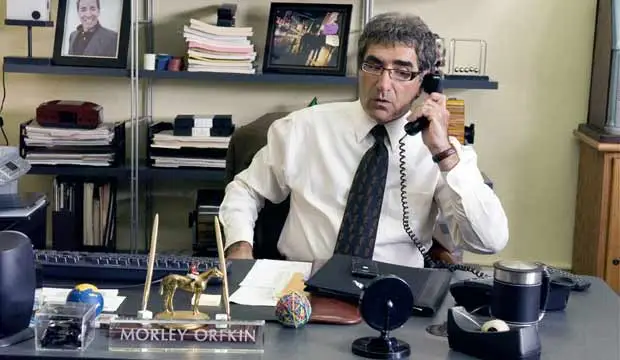How does the setting contribute to the ambiance of the scene? The office setting, with its practical furnishings and personal memorabilia, creates an intimate yet professional ambiance. This backdrop might emphasize the character's profound connection with his work, possibly inferring his dedication or the nature of his profession. Is there anything in the picture that suggests the character's personality or backstory? The unique combination of items like the framed photo, which possibly portrays a personal achievement or relation, along with the orderly yet eclectic mix of office items, portrays a character with a rich backstory. These details suggest a multifaceted personality, combining professional rigor with personal depth and eccentricities. 